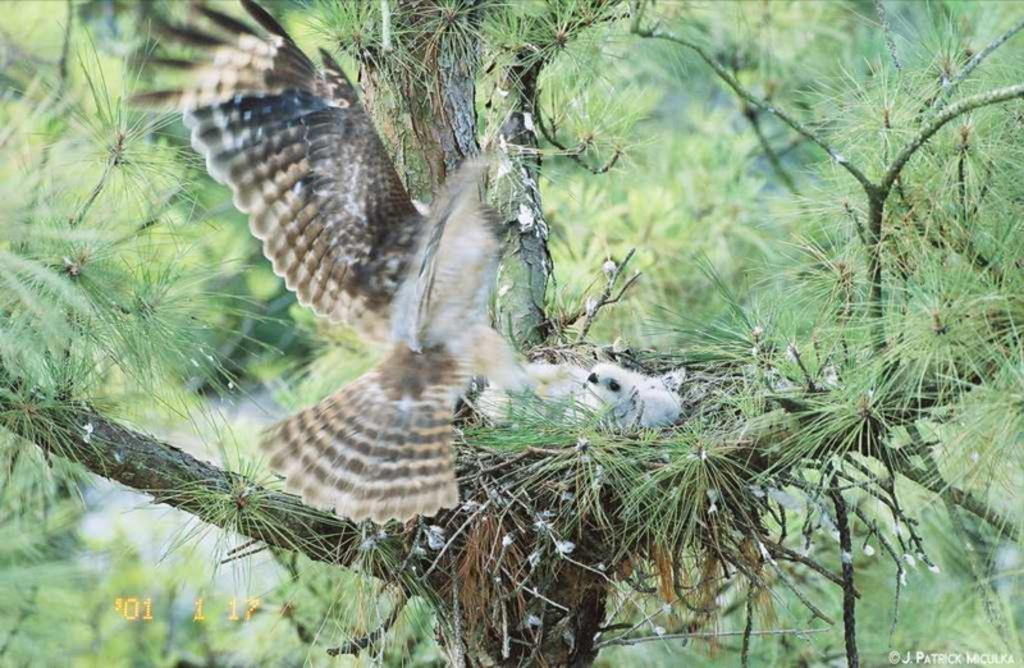What type of animals can be seen in the image? There are birds visible on a nest in the image. Where is the nest located? The nest is attached to a tree. What can be seen in the background of the image? There is a group of trees in the background of the image. What type of honey can be seen dripping from the twig in the image? There is no twig or honey present in the image. 